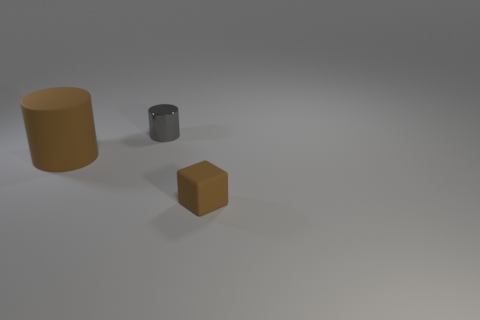Can you tell me the positions of the objects relative to one another? Certainly! If we consider the image as having a frontal perspective, the large cylindrical object is situated to the left side of the composition. The small gray metal cylinder is positioned in the central part of the image but behind the large cylinder from our point of view. Lastly, the cube is placed in the foreground and to the left of the small metal cylinder, making it appear closer to us. 